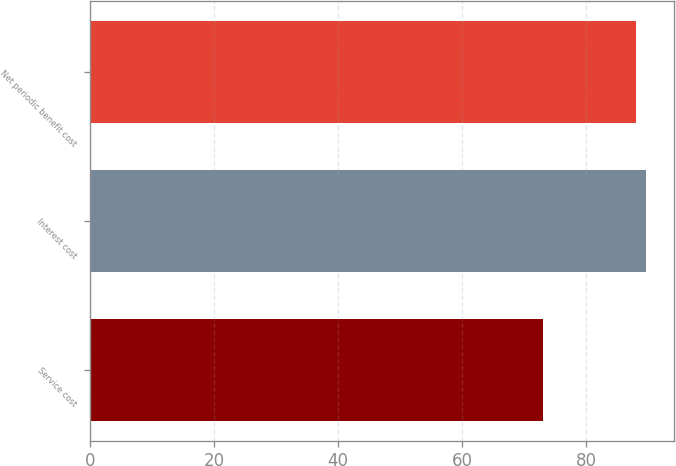<chart> <loc_0><loc_0><loc_500><loc_500><bar_chart><fcel>Service cost<fcel>Interest cost<fcel>Net periodic benefit cost<nl><fcel>73<fcel>89.6<fcel>88<nl></chart> 